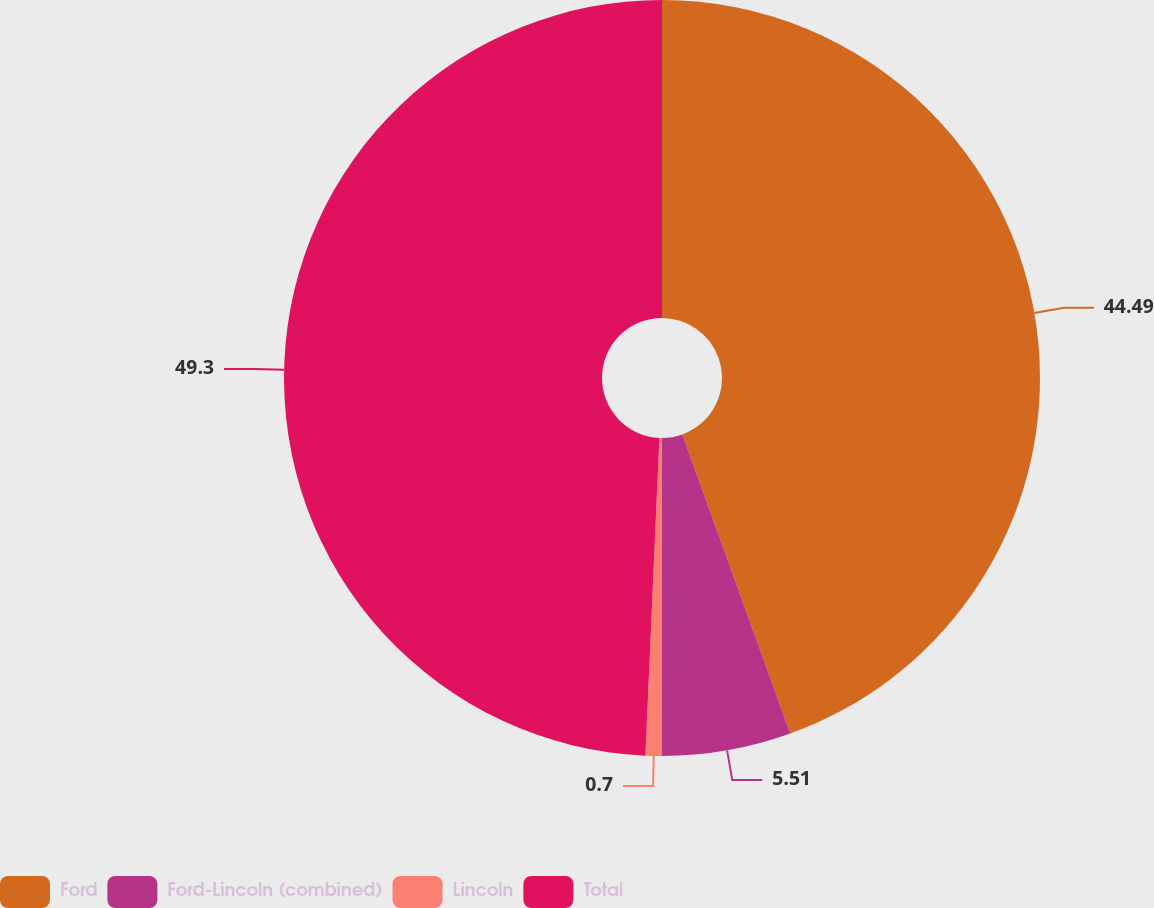<chart> <loc_0><loc_0><loc_500><loc_500><pie_chart><fcel>Ford<fcel>Ford-Lincoln (combined)<fcel>Lincoln<fcel>Total<nl><fcel>44.49%<fcel>5.51%<fcel>0.7%<fcel>49.3%<nl></chart> 